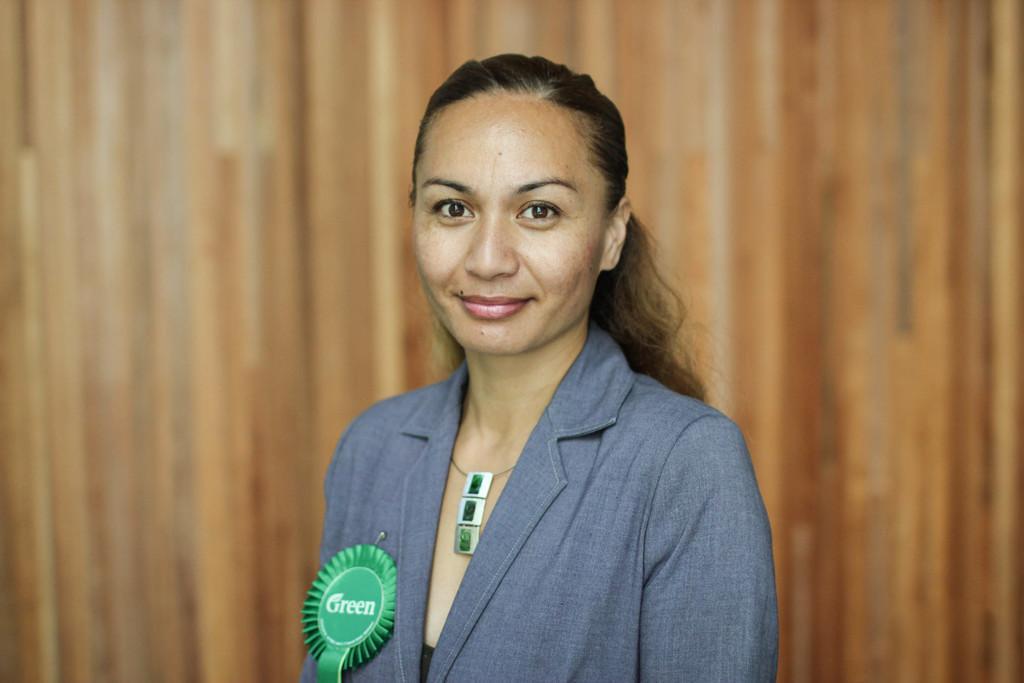How would you summarize this image in a sentence or two? In this image I can see a woman. I can see the green batch. I can also see the background is brown in color. 